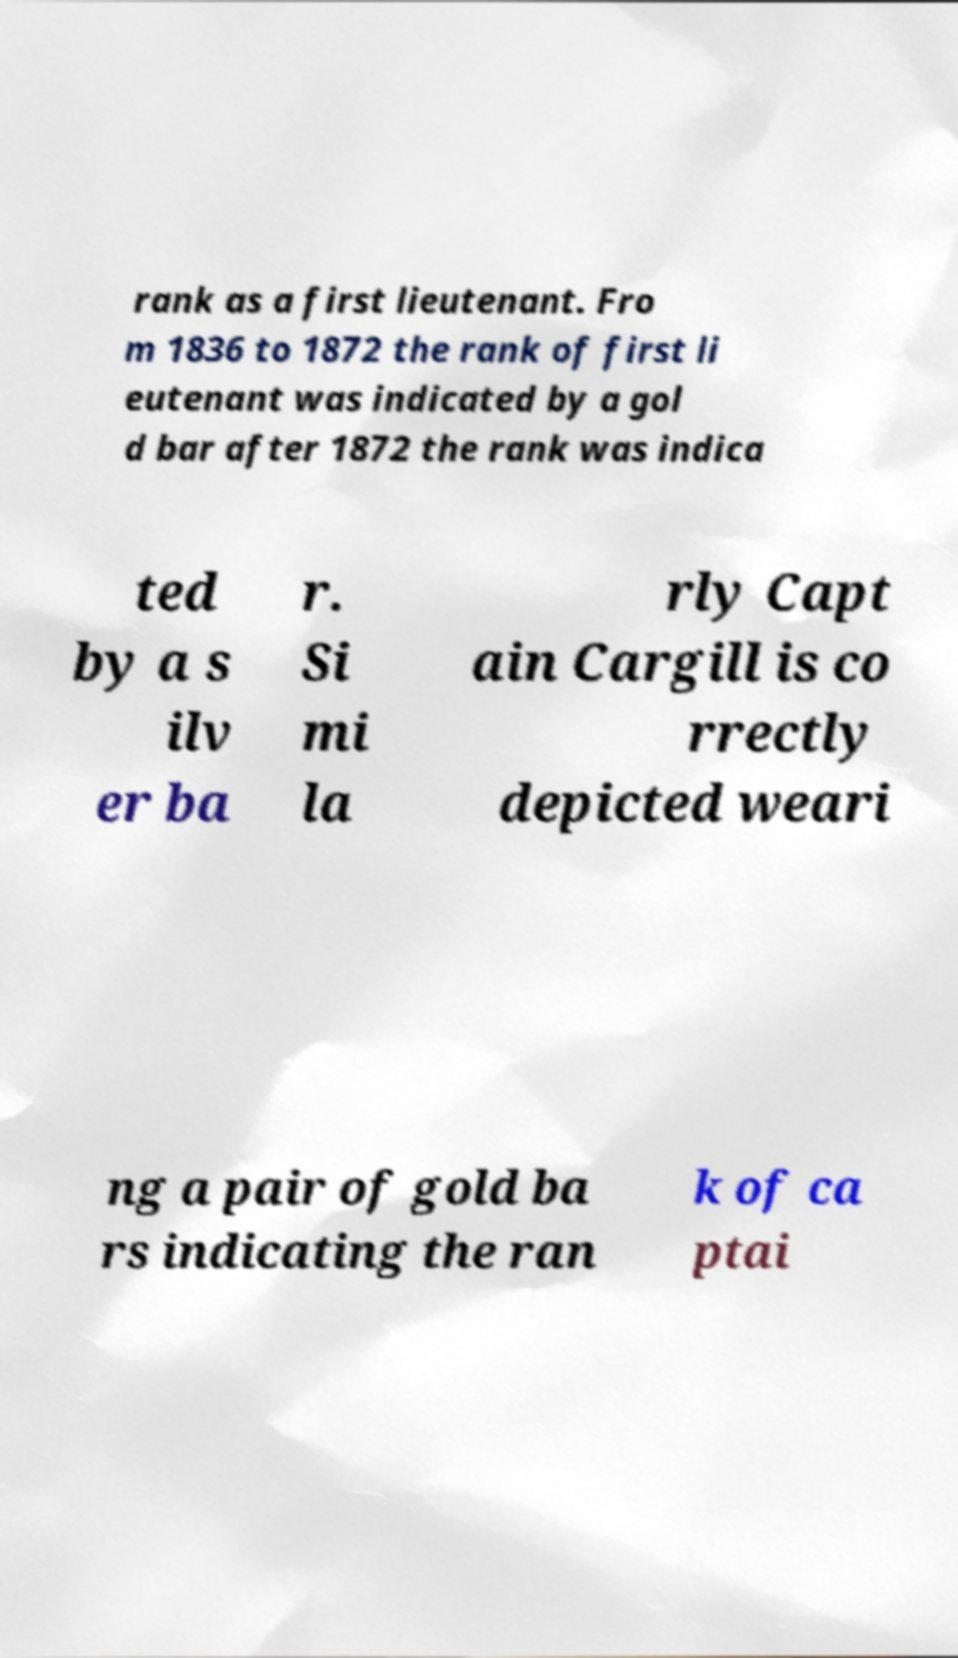What messages or text are displayed in this image? I need them in a readable, typed format. rank as a first lieutenant. Fro m 1836 to 1872 the rank of first li eutenant was indicated by a gol d bar after 1872 the rank was indica ted by a s ilv er ba r. Si mi la rly Capt ain Cargill is co rrectly depicted weari ng a pair of gold ba rs indicating the ran k of ca ptai 